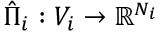<formula> <loc_0><loc_0><loc_500><loc_500>\hat { \Pi } _ { i } \colon V _ { i } \rightarrow \mathbb { R } ^ { N _ { i } }</formula> 